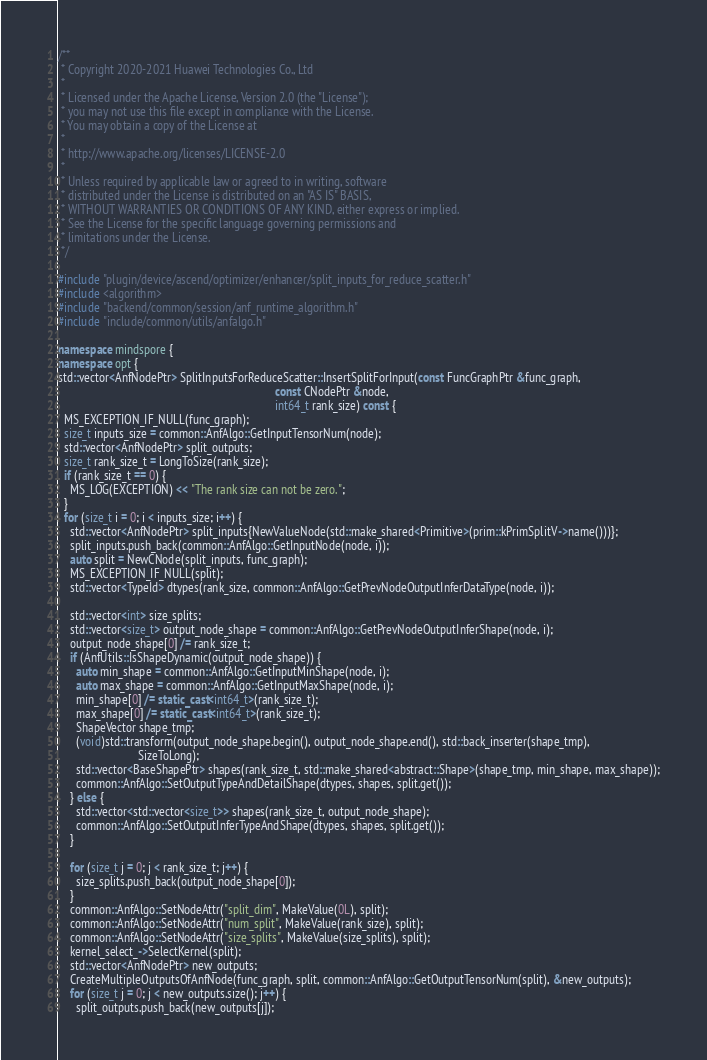Convert code to text. <code><loc_0><loc_0><loc_500><loc_500><_C++_>/**
 * Copyright 2020-2021 Huawei Technologies Co., Ltd
 *
 * Licensed under the Apache License, Version 2.0 (the "License");
 * you may not use this file except in compliance with the License.
 * You may obtain a copy of the License at
 *
 * http://www.apache.org/licenses/LICENSE-2.0
 *
 * Unless required by applicable law or agreed to in writing, software
 * distributed under the License is distributed on an "AS IS" BASIS,
 * WITHOUT WARRANTIES OR CONDITIONS OF ANY KIND, either express or implied.
 * See the License for the specific language governing permissions and
 * limitations under the License.
 */

#include "plugin/device/ascend/optimizer/enhancer/split_inputs_for_reduce_scatter.h"
#include <algorithm>
#include "backend/common/session/anf_runtime_algorithm.h"
#include "include/common/utils/anfalgo.h"

namespace mindspore {
namespace opt {
std::vector<AnfNodePtr> SplitInputsForReduceScatter::InsertSplitForInput(const FuncGraphPtr &func_graph,
                                                                         const CNodePtr &node,
                                                                         int64_t rank_size) const {
  MS_EXCEPTION_IF_NULL(func_graph);
  size_t inputs_size = common::AnfAlgo::GetInputTensorNum(node);
  std::vector<AnfNodePtr> split_outputs;
  size_t rank_size_t = LongToSize(rank_size);
  if (rank_size_t == 0) {
    MS_LOG(EXCEPTION) << "The rank size can not be zero.";
  }
  for (size_t i = 0; i < inputs_size; i++) {
    std::vector<AnfNodePtr> split_inputs{NewValueNode(std::make_shared<Primitive>(prim::kPrimSplitV->name()))};
    split_inputs.push_back(common::AnfAlgo::GetInputNode(node, i));
    auto split = NewCNode(split_inputs, func_graph);
    MS_EXCEPTION_IF_NULL(split);
    std::vector<TypeId> dtypes(rank_size, common::AnfAlgo::GetPrevNodeOutputInferDataType(node, i));

    std::vector<int> size_splits;
    std::vector<size_t> output_node_shape = common::AnfAlgo::GetPrevNodeOutputInferShape(node, i);
    output_node_shape[0] /= rank_size_t;
    if (AnfUtils::IsShapeDynamic(output_node_shape)) {
      auto min_shape = common::AnfAlgo::GetInputMinShape(node, i);
      auto max_shape = common::AnfAlgo::GetInputMaxShape(node, i);
      min_shape[0] /= static_cast<int64_t>(rank_size_t);
      max_shape[0] /= static_cast<int64_t>(rank_size_t);
      ShapeVector shape_tmp;
      (void)std::transform(output_node_shape.begin(), output_node_shape.end(), std::back_inserter(shape_tmp),
                           SizeToLong);
      std::vector<BaseShapePtr> shapes(rank_size_t, std::make_shared<abstract::Shape>(shape_tmp, min_shape, max_shape));
      common::AnfAlgo::SetOutputTypeAndDetailShape(dtypes, shapes, split.get());
    } else {
      std::vector<std::vector<size_t>> shapes(rank_size_t, output_node_shape);
      common::AnfAlgo::SetOutputInferTypeAndShape(dtypes, shapes, split.get());
    }

    for (size_t j = 0; j < rank_size_t; j++) {
      size_splits.push_back(output_node_shape[0]);
    }
    common::AnfAlgo::SetNodeAttr("split_dim", MakeValue(0L), split);
    common::AnfAlgo::SetNodeAttr("num_split", MakeValue(rank_size), split);
    common::AnfAlgo::SetNodeAttr("size_splits", MakeValue(size_splits), split);
    kernel_select_->SelectKernel(split);
    std::vector<AnfNodePtr> new_outputs;
    CreateMultipleOutputsOfAnfNode(func_graph, split, common::AnfAlgo::GetOutputTensorNum(split), &new_outputs);
    for (size_t j = 0; j < new_outputs.size(); j++) {
      split_outputs.push_back(new_outputs[j]);</code> 